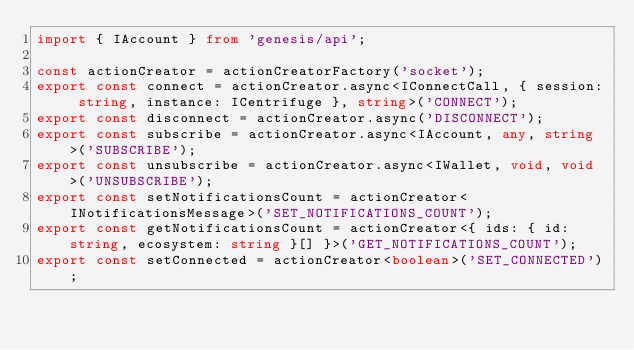<code> <loc_0><loc_0><loc_500><loc_500><_TypeScript_>import { IAccount } from 'genesis/api';

const actionCreator = actionCreatorFactory('socket');
export const connect = actionCreator.async<IConnectCall, { session: string, instance: ICentrifuge }, string>('CONNECT');
export const disconnect = actionCreator.async('DISCONNECT');
export const subscribe = actionCreator.async<IAccount, any, string>('SUBSCRIBE');
export const unsubscribe = actionCreator.async<IWallet, void, void>('UNSUBSCRIBE');
export const setNotificationsCount = actionCreator<INotificationsMessage>('SET_NOTIFICATIONS_COUNT');
export const getNotificationsCount = actionCreator<{ ids: { id: string, ecosystem: string }[] }>('GET_NOTIFICATIONS_COUNT');
export const setConnected = actionCreator<boolean>('SET_CONNECTED');</code> 